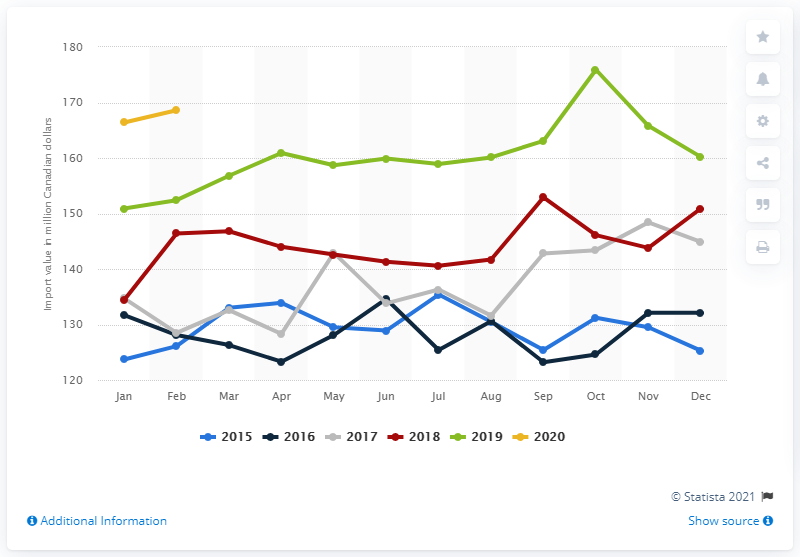Identify some key points in this picture. In February 2020, the import value of animal feed in Canada was CAD 168.6 million. 